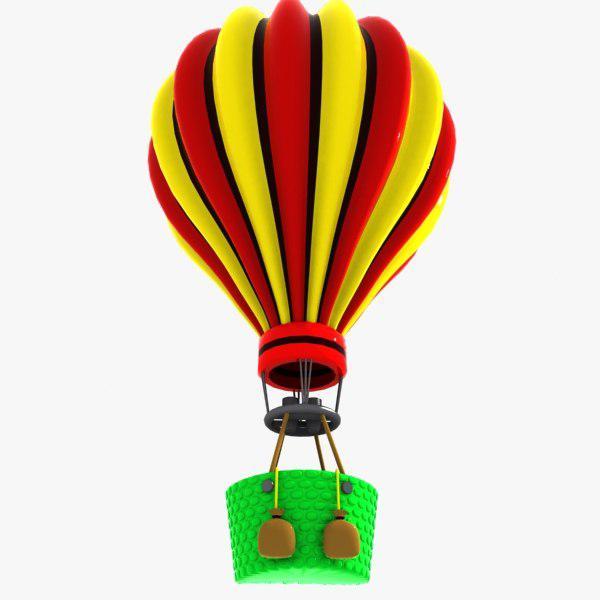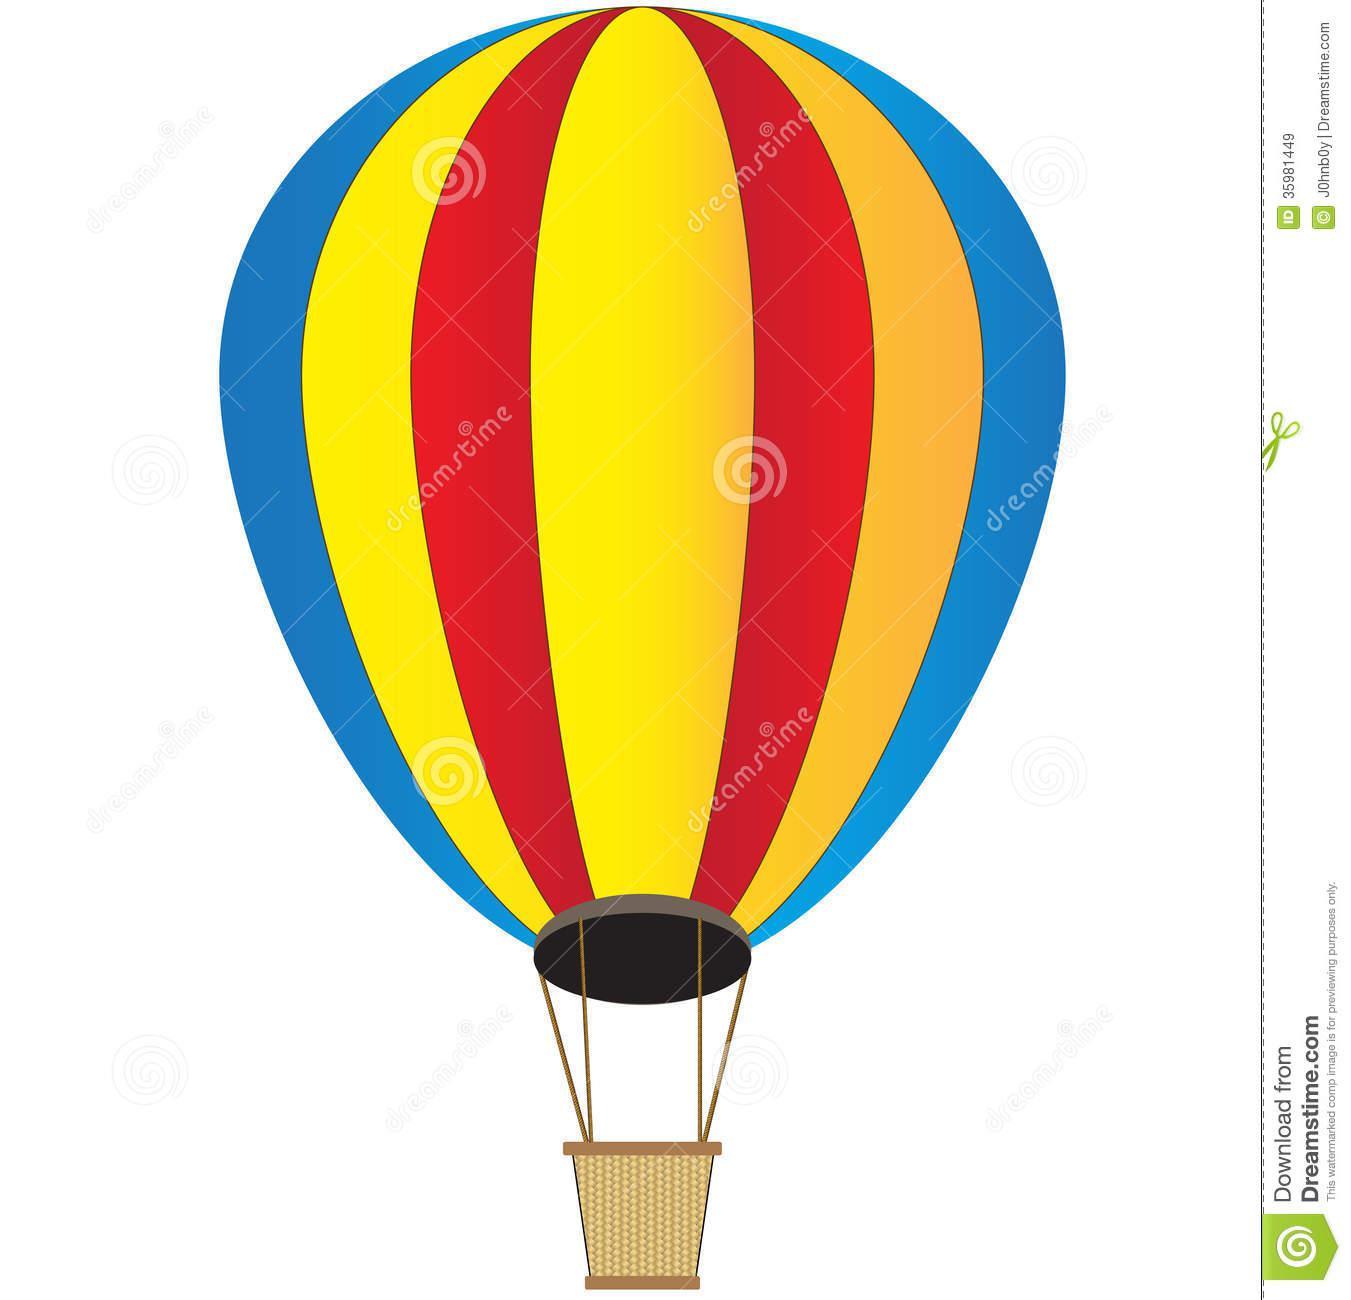The first image is the image on the left, the second image is the image on the right. Analyze the images presented: Is the assertion "No images show balloons against blue sky." valid? Answer yes or no. Yes. 